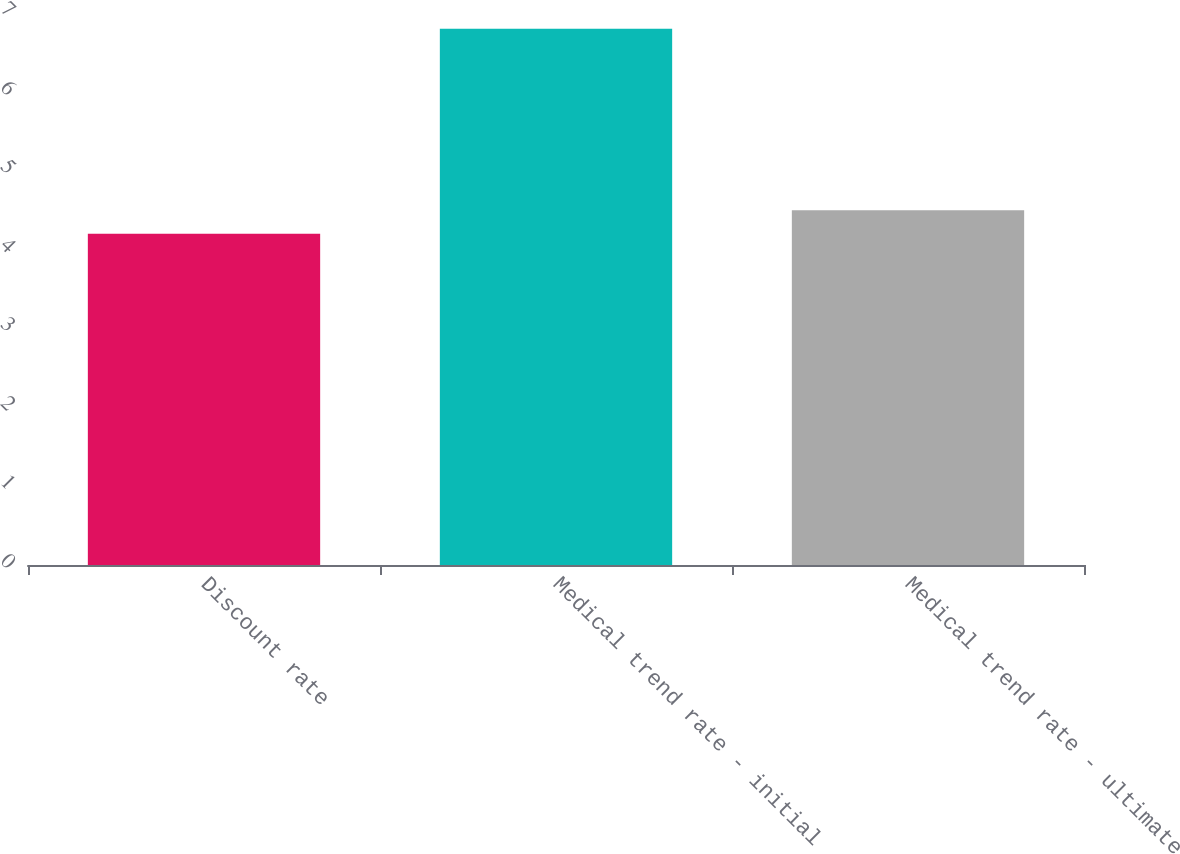Convert chart to OTSL. <chart><loc_0><loc_0><loc_500><loc_500><bar_chart><fcel>Discount rate<fcel>Medical trend rate - initial<fcel>Medical trend rate - ultimate<nl><fcel>4.2<fcel>6.8<fcel>4.5<nl></chart> 